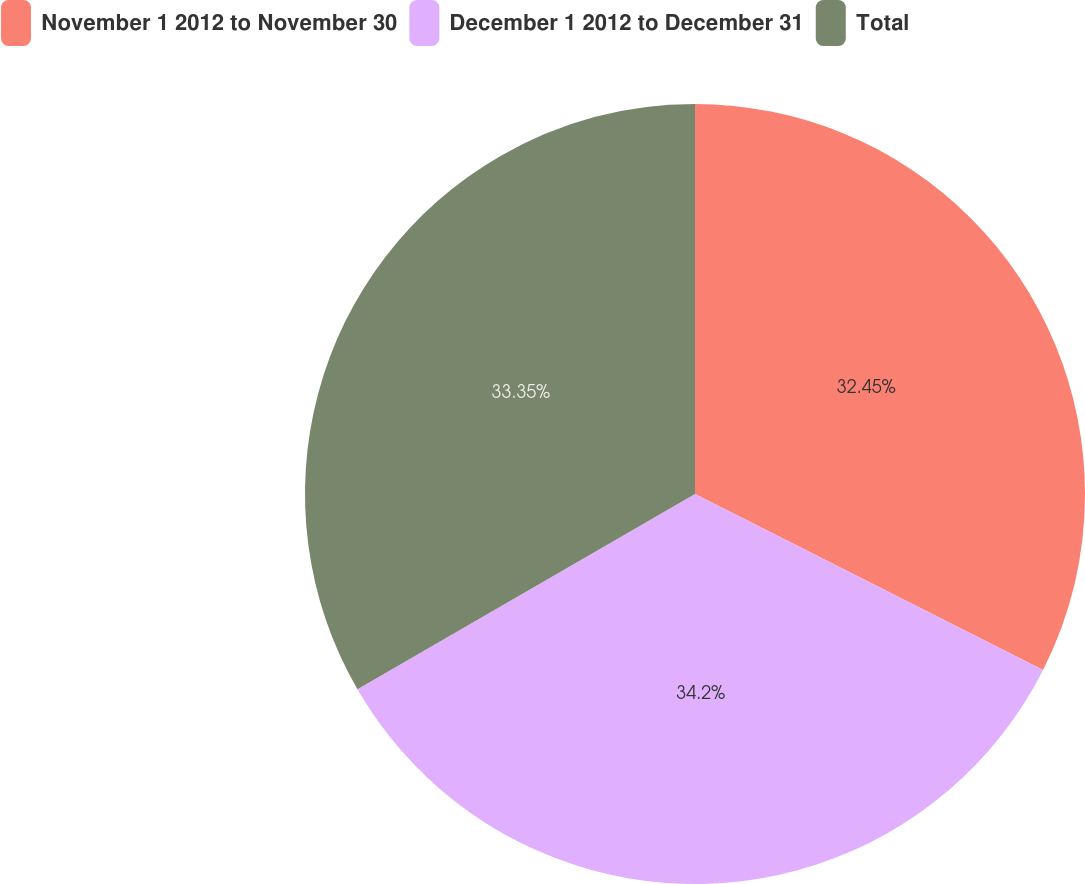<chart> <loc_0><loc_0><loc_500><loc_500><pie_chart><fcel>November 1 2012 to November 30<fcel>December 1 2012 to December 31<fcel>Total<nl><fcel>32.45%<fcel>34.2%<fcel>33.35%<nl></chart> 